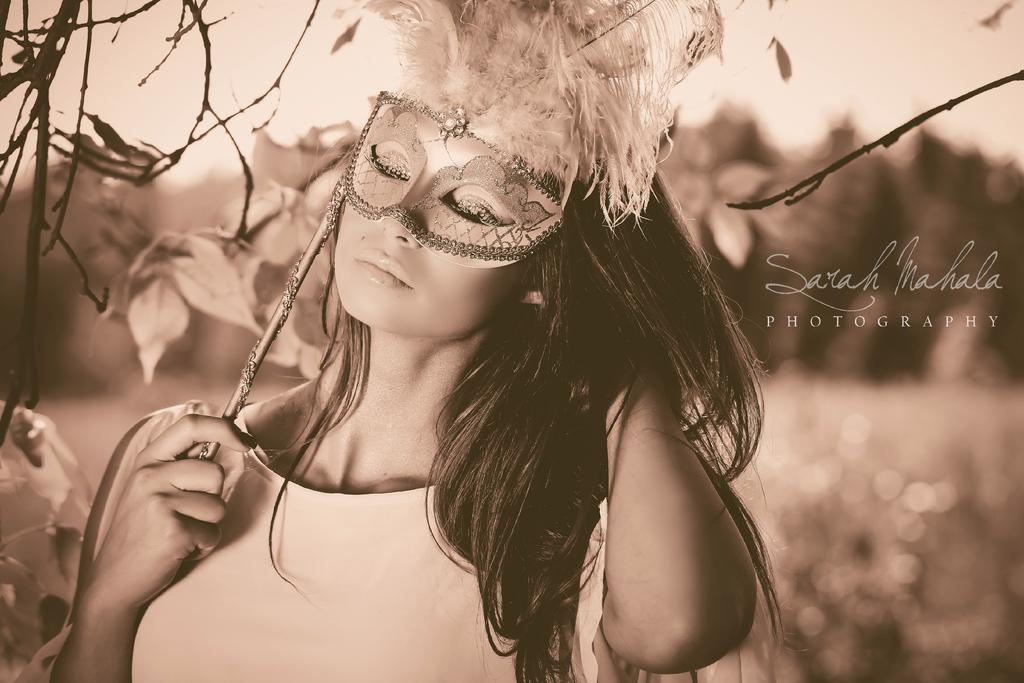Who is the main subject in the image? There is a lady in the image. What is the lady holding in the image? The lady is holding an artificial eye mask. What can be seen in the background of the image? There is text, twigs, and leaves visible in the background of the image. How does the zebra contribute to the lady's knowledge in the image? There is no zebra present in the image, so it cannot contribute to the lady's knowledge. What type of ground is visible in the image? There is no specific ground mentioned or visible in the image; only text, twigs, and leaves are mentioned in the background. 